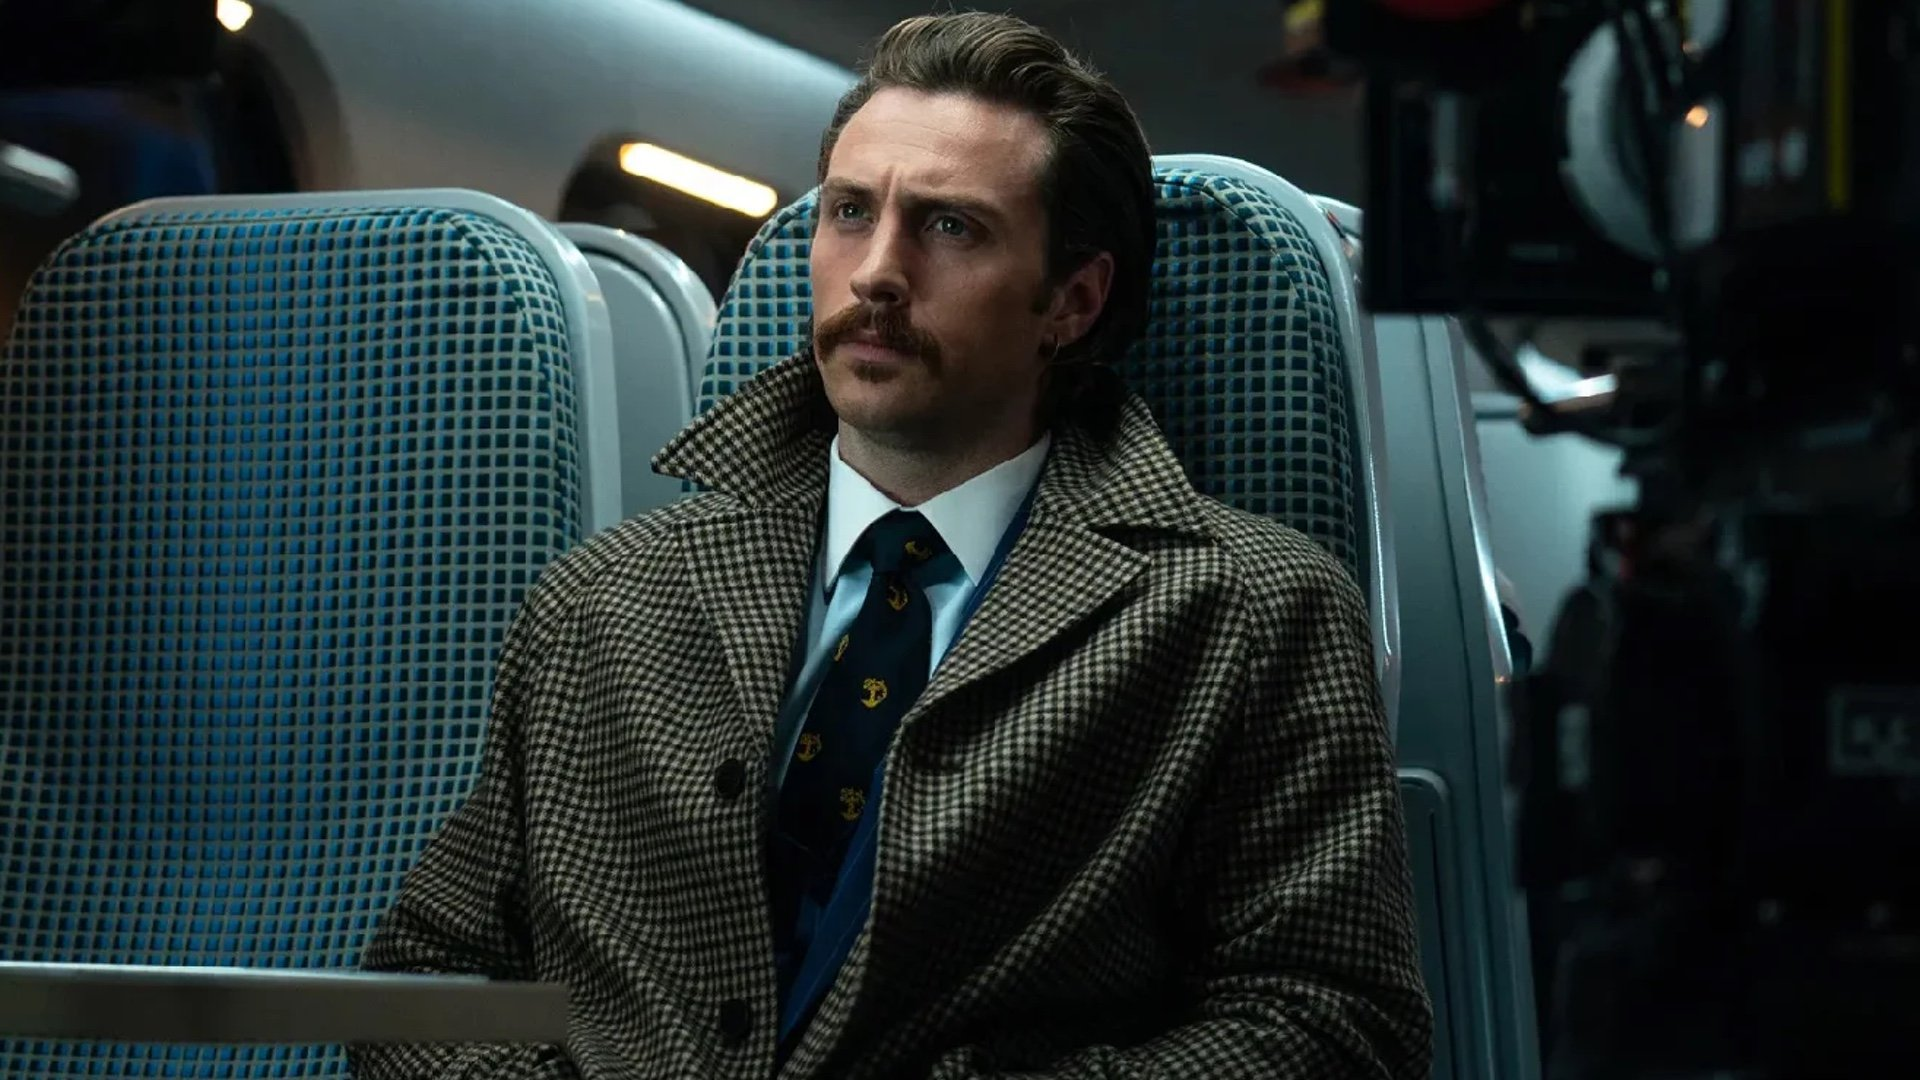What might be the thoughts going through his mind in this moment? Given the serious and reflective demeanor, he might be contemplating a recent unsettling event or planning a decisive next step in his journey. The dark narrative of the movie often places characters in positions where they confront deep-seated fears or moral dilemmas. Could this scene be symbolic in any way? Yes, this scene could symbolize isolation and introspection, common themes in the film. The train's movement might represent the inevitable progression of life's events, with the character caught in the flow of decisions and consequences he cannot escape. 